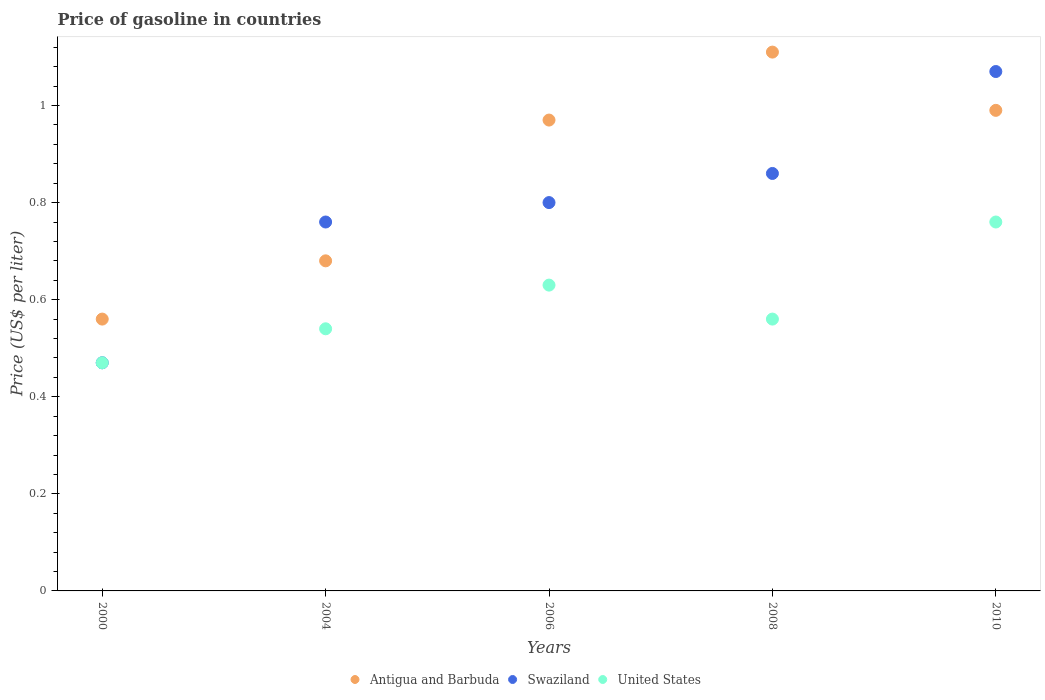Is the number of dotlines equal to the number of legend labels?
Give a very brief answer. Yes. What is the price of gasoline in Swaziland in 2008?
Give a very brief answer. 0.86. Across all years, what is the maximum price of gasoline in Swaziland?
Keep it short and to the point. 1.07. Across all years, what is the minimum price of gasoline in Swaziland?
Ensure brevity in your answer.  0.47. In which year was the price of gasoline in Swaziland maximum?
Make the answer very short. 2010. In which year was the price of gasoline in Antigua and Barbuda minimum?
Your response must be concise. 2000. What is the total price of gasoline in Antigua and Barbuda in the graph?
Offer a terse response. 4.31. What is the difference between the price of gasoline in United States in 2006 and that in 2008?
Give a very brief answer. 0.07. What is the difference between the price of gasoline in United States in 2006 and the price of gasoline in Antigua and Barbuda in 2010?
Keep it short and to the point. -0.36. What is the average price of gasoline in Swaziland per year?
Provide a short and direct response. 0.79. In the year 2000, what is the difference between the price of gasoline in Swaziland and price of gasoline in United States?
Make the answer very short. 0. In how many years, is the price of gasoline in Swaziland greater than 0.36 US$?
Make the answer very short. 5. What is the ratio of the price of gasoline in Antigua and Barbuda in 2004 to that in 2008?
Your response must be concise. 0.61. Is the price of gasoline in United States in 2006 less than that in 2010?
Your answer should be very brief. Yes. Is the difference between the price of gasoline in Swaziland in 2004 and 2008 greater than the difference between the price of gasoline in United States in 2004 and 2008?
Make the answer very short. No. What is the difference between the highest and the second highest price of gasoline in Antigua and Barbuda?
Ensure brevity in your answer.  0.12. What is the difference between the highest and the lowest price of gasoline in United States?
Your answer should be very brief. 0.29. Is the sum of the price of gasoline in United States in 2006 and 2010 greater than the maximum price of gasoline in Swaziland across all years?
Make the answer very short. Yes. Is the price of gasoline in Swaziland strictly greater than the price of gasoline in Antigua and Barbuda over the years?
Keep it short and to the point. No. Is the price of gasoline in United States strictly less than the price of gasoline in Antigua and Barbuda over the years?
Give a very brief answer. Yes. How many years are there in the graph?
Your answer should be compact. 5. Does the graph contain any zero values?
Your answer should be very brief. No. Does the graph contain grids?
Your answer should be compact. No. Where does the legend appear in the graph?
Offer a very short reply. Bottom center. What is the title of the graph?
Provide a short and direct response. Price of gasoline in countries. Does "Jamaica" appear as one of the legend labels in the graph?
Offer a terse response. No. What is the label or title of the X-axis?
Provide a short and direct response. Years. What is the label or title of the Y-axis?
Provide a succinct answer. Price (US$ per liter). What is the Price (US$ per liter) of Antigua and Barbuda in 2000?
Give a very brief answer. 0.56. What is the Price (US$ per liter) in Swaziland in 2000?
Your response must be concise. 0.47. What is the Price (US$ per liter) in United States in 2000?
Provide a short and direct response. 0.47. What is the Price (US$ per liter) in Antigua and Barbuda in 2004?
Provide a succinct answer. 0.68. What is the Price (US$ per liter) in Swaziland in 2004?
Keep it short and to the point. 0.76. What is the Price (US$ per liter) of United States in 2004?
Offer a terse response. 0.54. What is the Price (US$ per liter) of United States in 2006?
Your answer should be compact. 0.63. What is the Price (US$ per liter) of Antigua and Barbuda in 2008?
Make the answer very short. 1.11. What is the Price (US$ per liter) of Swaziland in 2008?
Your answer should be compact. 0.86. What is the Price (US$ per liter) in United States in 2008?
Ensure brevity in your answer.  0.56. What is the Price (US$ per liter) in Antigua and Barbuda in 2010?
Make the answer very short. 0.99. What is the Price (US$ per liter) of Swaziland in 2010?
Your answer should be compact. 1.07. What is the Price (US$ per liter) of United States in 2010?
Provide a succinct answer. 0.76. Across all years, what is the maximum Price (US$ per liter) of Antigua and Barbuda?
Your response must be concise. 1.11. Across all years, what is the maximum Price (US$ per liter) of Swaziland?
Your answer should be very brief. 1.07. Across all years, what is the maximum Price (US$ per liter) in United States?
Offer a terse response. 0.76. Across all years, what is the minimum Price (US$ per liter) of Antigua and Barbuda?
Provide a short and direct response. 0.56. Across all years, what is the minimum Price (US$ per liter) of Swaziland?
Your answer should be compact. 0.47. Across all years, what is the minimum Price (US$ per liter) of United States?
Provide a short and direct response. 0.47. What is the total Price (US$ per liter) of Antigua and Barbuda in the graph?
Make the answer very short. 4.31. What is the total Price (US$ per liter) of Swaziland in the graph?
Offer a terse response. 3.96. What is the total Price (US$ per liter) in United States in the graph?
Keep it short and to the point. 2.96. What is the difference between the Price (US$ per liter) in Antigua and Barbuda in 2000 and that in 2004?
Provide a succinct answer. -0.12. What is the difference between the Price (US$ per liter) of Swaziland in 2000 and that in 2004?
Make the answer very short. -0.29. What is the difference between the Price (US$ per liter) of United States in 2000 and that in 2004?
Your answer should be compact. -0.07. What is the difference between the Price (US$ per liter) in Antigua and Barbuda in 2000 and that in 2006?
Offer a very short reply. -0.41. What is the difference between the Price (US$ per liter) of Swaziland in 2000 and that in 2006?
Offer a terse response. -0.33. What is the difference between the Price (US$ per liter) of United States in 2000 and that in 2006?
Ensure brevity in your answer.  -0.16. What is the difference between the Price (US$ per liter) in Antigua and Barbuda in 2000 and that in 2008?
Provide a short and direct response. -0.55. What is the difference between the Price (US$ per liter) of Swaziland in 2000 and that in 2008?
Your answer should be very brief. -0.39. What is the difference between the Price (US$ per liter) in United States in 2000 and that in 2008?
Keep it short and to the point. -0.09. What is the difference between the Price (US$ per liter) in Antigua and Barbuda in 2000 and that in 2010?
Provide a succinct answer. -0.43. What is the difference between the Price (US$ per liter) in Swaziland in 2000 and that in 2010?
Provide a short and direct response. -0.6. What is the difference between the Price (US$ per liter) in United States in 2000 and that in 2010?
Keep it short and to the point. -0.29. What is the difference between the Price (US$ per liter) of Antigua and Barbuda in 2004 and that in 2006?
Ensure brevity in your answer.  -0.29. What is the difference between the Price (US$ per liter) of Swaziland in 2004 and that in 2006?
Offer a terse response. -0.04. What is the difference between the Price (US$ per liter) of United States in 2004 and that in 2006?
Offer a very short reply. -0.09. What is the difference between the Price (US$ per liter) of Antigua and Barbuda in 2004 and that in 2008?
Keep it short and to the point. -0.43. What is the difference between the Price (US$ per liter) of Swaziland in 2004 and that in 2008?
Your answer should be very brief. -0.1. What is the difference between the Price (US$ per liter) of United States in 2004 and that in 2008?
Give a very brief answer. -0.02. What is the difference between the Price (US$ per liter) in Antigua and Barbuda in 2004 and that in 2010?
Your response must be concise. -0.31. What is the difference between the Price (US$ per liter) in Swaziland in 2004 and that in 2010?
Provide a short and direct response. -0.31. What is the difference between the Price (US$ per liter) in United States in 2004 and that in 2010?
Your response must be concise. -0.22. What is the difference between the Price (US$ per liter) in Antigua and Barbuda in 2006 and that in 2008?
Ensure brevity in your answer.  -0.14. What is the difference between the Price (US$ per liter) of Swaziland in 2006 and that in 2008?
Your response must be concise. -0.06. What is the difference between the Price (US$ per liter) of United States in 2006 and that in 2008?
Give a very brief answer. 0.07. What is the difference between the Price (US$ per liter) of Antigua and Barbuda in 2006 and that in 2010?
Provide a short and direct response. -0.02. What is the difference between the Price (US$ per liter) of Swaziland in 2006 and that in 2010?
Ensure brevity in your answer.  -0.27. What is the difference between the Price (US$ per liter) of United States in 2006 and that in 2010?
Your response must be concise. -0.13. What is the difference between the Price (US$ per liter) of Antigua and Barbuda in 2008 and that in 2010?
Offer a very short reply. 0.12. What is the difference between the Price (US$ per liter) in Swaziland in 2008 and that in 2010?
Ensure brevity in your answer.  -0.21. What is the difference between the Price (US$ per liter) of Swaziland in 2000 and the Price (US$ per liter) of United States in 2004?
Give a very brief answer. -0.07. What is the difference between the Price (US$ per liter) in Antigua and Barbuda in 2000 and the Price (US$ per liter) in Swaziland in 2006?
Provide a succinct answer. -0.24. What is the difference between the Price (US$ per liter) of Antigua and Barbuda in 2000 and the Price (US$ per liter) of United States in 2006?
Ensure brevity in your answer.  -0.07. What is the difference between the Price (US$ per liter) in Swaziland in 2000 and the Price (US$ per liter) in United States in 2006?
Ensure brevity in your answer.  -0.16. What is the difference between the Price (US$ per liter) in Antigua and Barbuda in 2000 and the Price (US$ per liter) in Swaziland in 2008?
Keep it short and to the point. -0.3. What is the difference between the Price (US$ per liter) of Swaziland in 2000 and the Price (US$ per liter) of United States in 2008?
Your response must be concise. -0.09. What is the difference between the Price (US$ per liter) of Antigua and Barbuda in 2000 and the Price (US$ per liter) of Swaziland in 2010?
Ensure brevity in your answer.  -0.51. What is the difference between the Price (US$ per liter) of Swaziland in 2000 and the Price (US$ per liter) of United States in 2010?
Your answer should be very brief. -0.29. What is the difference between the Price (US$ per liter) of Antigua and Barbuda in 2004 and the Price (US$ per liter) of Swaziland in 2006?
Provide a succinct answer. -0.12. What is the difference between the Price (US$ per liter) in Swaziland in 2004 and the Price (US$ per liter) in United States in 2006?
Offer a very short reply. 0.13. What is the difference between the Price (US$ per liter) in Antigua and Barbuda in 2004 and the Price (US$ per liter) in Swaziland in 2008?
Ensure brevity in your answer.  -0.18. What is the difference between the Price (US$ per liter) in Antigua and Barbuda in 2004 and the Price (US$ per liter) in United States in 2008?
Offer a very short reply. 0.12. What is the difference between the Price (US$ per liter) of Swaziland in 2004 and the Price (US$ per liter) of United States in 2008?
Keep it short and to the point. 0.2. What is the difference between the Price (US$ per liter) in Antigua and Barbuda in 2004 and the Price (US$ per liter) in Swaziland in 2010?
Your response must be concise. -0.39. What is the difference between the Price (US$ per liter) of Antigua and Barbuda in 2004 and the Price (US$ per liter) of United States in 2010?
Your response must be concise. -0.08. What is the difference between the Price (US$ per liter) in Swaziland in 2004 and the Price (US$ per liter) in United States in 2010?
Make the answer very short. 0. What is the difference between the Price (US$ per liter) in Antigua and Barbuda in 2006 and the Price (US$ per liter) in Swaziland in 2008?
Your response must be concise. 0.11. What is the difference between the Price (US$ per liter) of Antigua and Barbuda in 2006 and the Price (US$ per liter) of United States in 2008?
Provide a succinct answer. 0.41. What is the difference between the Price (US$ per liter) of Swaziland in 2006 and the Price (US$ per liter) of United States in 2008?
Offer a very short reply. 0.24. What is the difference between the Price (US$ per liter) of Antigua and Barbuda in 2006 and the Price (US$ per liter) of Swaziland in 2010?
Your answer should be compact. -0.1. What is the difference between the Price (US$ per liter) in Antigua and Barbuda in 2006 and the Price (US$ per liter) in United States in 2010?
Give a very brief answer. 0.21. What is the difference between the Price (US$ per liter) of Swaziland in 2006 and the Price (US$ per liter) of United States in 2010?
Provide a short and direct response. 0.04. What is the difference between the Price (US$ per liter) in Antigua and Barbuda in 2008 and the Price (US$ per liter) in Swaziland in 2010?
Provide a succinct answer. 0.04. What is the difference between the Price (US$ per liter) in Antigua and Barbuda in 2008 and the Price (US$ per liter) in United States in 2010?
Your response must be concise. 0.35. What is the average Price (US$ per liter) of Antigua and Barbuda per year?
Give a very brief answer. 0.86. What is the average Price (US$ per liter) of Swaziland per year?
Offer a terse response. 0.79. What is the average Price (US$ per liter) in United States per year?
Ensure brevity in your answer.  0.59. In the year 2000, what is the difference between the Price (US$ per liter) of Antigua and Barbuda and Price (US$ per liter) of Swaziland?
Offer a very short reply. 0.09. In the year 2000, what is the difference between the Price (US$ per liter) in Antigua and Barbuda and Price (US$ per liter) in United States?
Ensure brevity in your answer.  0.09. In the year 2000, what is the difference between the Price (US$ per liter) of Swaziland and Price (US$ per liter) of United States?
Make the answer very short. 0. In the year 2004, what is the difference between the Price (US$ per liter) of Antigua and Barbuda and Price (US$ per liter) of Swaziland?
Your answer should be compact. -0.08. In the year 2004, what is the difference between the Price (US$ per liter) of Antigua and Barbuda and Price (US$ per liter) of United States?
Your answer should be compact. 0.14. In the year 2004, what is the difference between the Price (US$ per liter) of Swaziland and Price (US$ per liter) of United States?
Your answer should be compact. 0.22. In the year 2006, what is the difference between the Price (US$ per liter) of Antigua and Barbuda and Price (US$ per liter) of Swaziland?
Ensure brevity in your answer.  0.17. In the year 2006, what is the difference between the Price (US$ per liter) of Antigua and Barbuda and Price (US$ per liter) of United States?
Offer a terse response. 0.34. In the year 2006, what is the difference between the Price (US$ per liter) of Swaziland and Price (US$ per liter) of United States?
Your response must be concise. 0.17. In the year 2008, what is the difference between the Price (US$ per liter) in Antigua and Barbuda and Price (US$ per liter) in United States?
Give a very brief answer. 0.55. In the year 2008, what is the difference between the Price (US$ per liter) of Swaziland and Price (US$ per liter) of United States?
Offer a very short reply. 0.3. In the year 2010, what is the difference between the Price (US$ per liter) in Antigua and Barbuda and Price (US$ per liter) in Swaziland?
Your response must be concise. -0.08. In the year 2010, what is the difference between the Price (US$ per liter) of Antigua and Barbuda and Price (US$ per liter) of United States?
Offer a terse response. 0.23. In the year 2010, what is the difference between the Price (US$ per liter) of Swaziland and Price (US$ per liter) of United States?
Offer a terse response. 0.31. What is the ratio of the Price (US$ per liter) of Antigua and Barbuda in 2000 to that in 2004?
Keep it short and to the point. 0.82. What is the ratio of the Price (US$ per liter) of Swaziland in 2000 to that in 2004?
Offer a very short reply. 0.62. What is the ratio of the Price (US$ per liter) of United States in 2000 to that in 2004?
Your answer should be very brief. 0.87. What is the ratio of the Price (US$ per liter) of Antigua and Barbuda in 2000 to that in 2006?
Your answer should be very brief. 0.58. What is the ratio of the Price (US$ per liter) in Swaziland in 2000 to that in 2006?
Keep it short and to the point. 0.59. What is the ratio of the Price (US$ per liter) in United States in 2000 to that in 2006?
Provide a short and direct response. 0.75. What is the ratio of the Price (US$ per liter) of Antigua and Barbuda in 2000 to that in 2008?
Keep it short and to the point. 0.5. What is the ratio of the Price (US$ per liter) in Swaziland in 2000 to that in 2008?
Your answer should be compact. 0.55. What is the ratio of the Price (US$ per liter) in United States in 2000 to that in 2008?
Make the answer very short. 0.84. What is the ratio of the Price (US$ per liter) in Antigua and Barbuda in 2000 to that in 2010?
Your answer should be very brief. 0.57. What is the ratio of the Price (US$ per liter) of Swaziland in 2000 to that in 2010?
Offer a terse response. 0.44. What is the ratio of the Price (US$ per liter) in United States in 2000 to that in 2010?
Provide a short and direct response. 0.62. What is the ratio of the Price (US$ per liter) in Antigua and Barbuda in 2004 to that in 2006?
Give a very brief answer. 0.7. What is the ratio of the Price (US$ per liter) in Swaziland in 2004 to that in 2006?
Provide a succinct answer. 0.95. What is the ratio of the Price (US$ per liter) in Antigua and Barbuda in 2004 to that in 2008?
Offer a very short reply. 0.61. What is the ratio of the Price (US$ per liter) in Swaziland in 2004 to that in 2008?
Keep it short and to the point. 0.88. What is the ratio of the Price (US$ per liter) of United States in 2004 to that in 2008?
Your answer should be compact. 0.96. What is the ratio of the Price (US$ per liter) of Antigua and Barbuda in 2004 to that in 2010?
Keep it short and to the point. 0.69. What is the ratio of the Price (US$ per liter) of Swaziland in 2004 to that in 2010?
Provide a short and direct response. 0.71. What is the ratio of the Price (US$ per liter) of United States in 2004 to that in 2010?
Keep it short and to the point. 0.71. What is the ratio of the Price (US$ per liter) of Antigua and Barbuda in 2006 to that in 2008?
Ensure brevity in your answer.  0.87. What is the ratio of the Price (US$ per liter) in Swaziland in 2006 to that in 2008?
Give a very brief answer. 0.93. What is the ratio of the Price (US$ per liter) of Antigua and Barbuda in 2006 to that in 2010?
Make the answer very short. 0.98. What is the ratio of the Price (US$ per liter) of Swaziland in 2006 to that in 2010?
Provide a short and direct response. 0.75. What is the ratio of the Price (US$ per liter) of United States in 2006 to that in 2010?
Offer a terse response. 0.83. What is the ratio of the Price (US$ per liter) of Antigua and Barbuda in 2008 to that in 2010?
Offer a very short reply. 1.12. What is the ratio of the Price (US$ per liter) of Swaziland in 2008 to that in 2010?
Keep it short and to the point. 0.8. What is the ratio of the Price (US$ per liter) of United States in 2008 to that in 2010?
Offer a terse response. 0.74. What is the difference between the highest and the second highest Price (US$ per liter) of Antigua and Barbuda?
Your answer should be very brief. 0.12. What is the difference between the highest and the second highest Price (US$ per liter) in Swaziland?
Make the answer very short. 0.21. What is the difference between the highest and the second highest Price (US$ per liter) in United States?
Offer a very short reply. 0.13. What is the difference between the highest and the lowest Price (US$ per liter) of Antigua and Barbuda?
Your answer should be very brief. 0.55. What is the difference between the highest and the lowest Price (US$ per liter) in Swaziland?
Your answer should be compact. 0.6. What is the difference between the highest and the lowest Price (US$ per liter) in United States?
Provide a succinct answer. 0.29. 